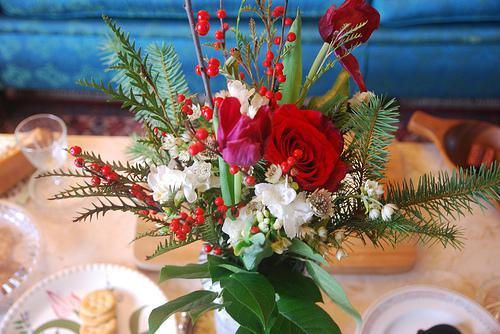Question: what is the big flower?
Choices:
A. Rose.
B. Petunia.
C. Lily.
D. Carnation.
Answer with the letter. Answer: A Question: what else is on the table?
Choices:
A. Cup.
B. Napkins.
C. Forks.
D. Plates.
Answer with the letter. Answer: D Question: where is this scene?
Choices:
A. Living room.
B. Bedroom.
C. Dinner table.
D. Bathroom.
Answer with the letter. Answer: C 